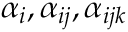<formula> <loc_0><loc_0><loc_500><loc_500>\alpha _ { i } , \alpha _ { i j } , \alpha _ { i j k }</formula> 